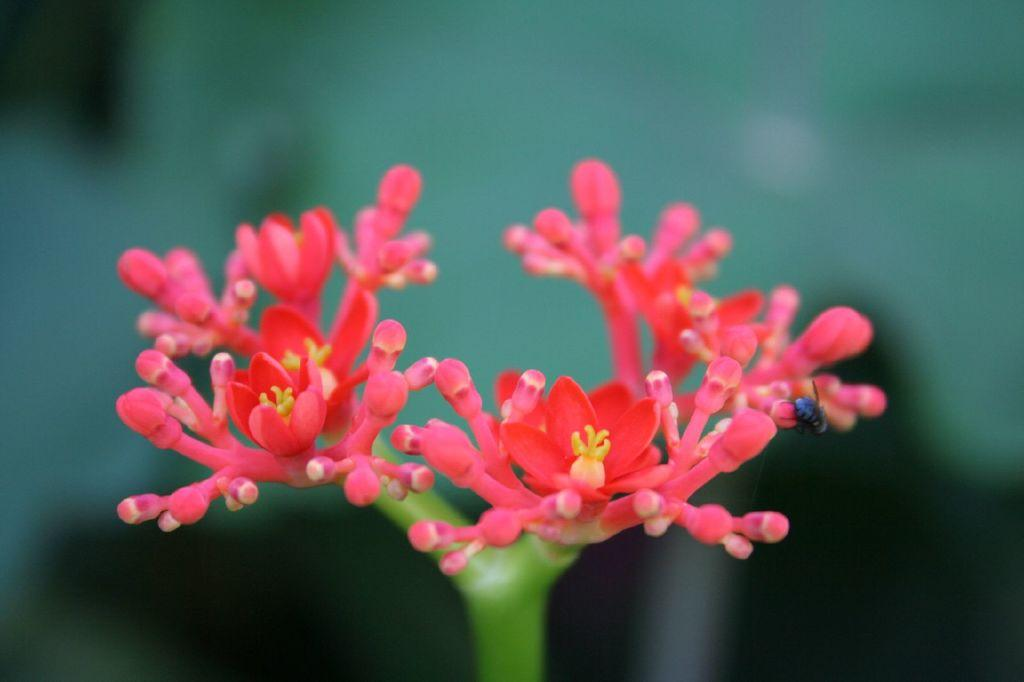What type of flora can be seen in the image? There are flowers in the image. What color are the flowers? The flowers are red in color. Can you describe the background of the image? The background of the image is blurred. What type of health issues are the flowers experiencing in the image? There is no indication of any health issues affecting the flowers in the image. 